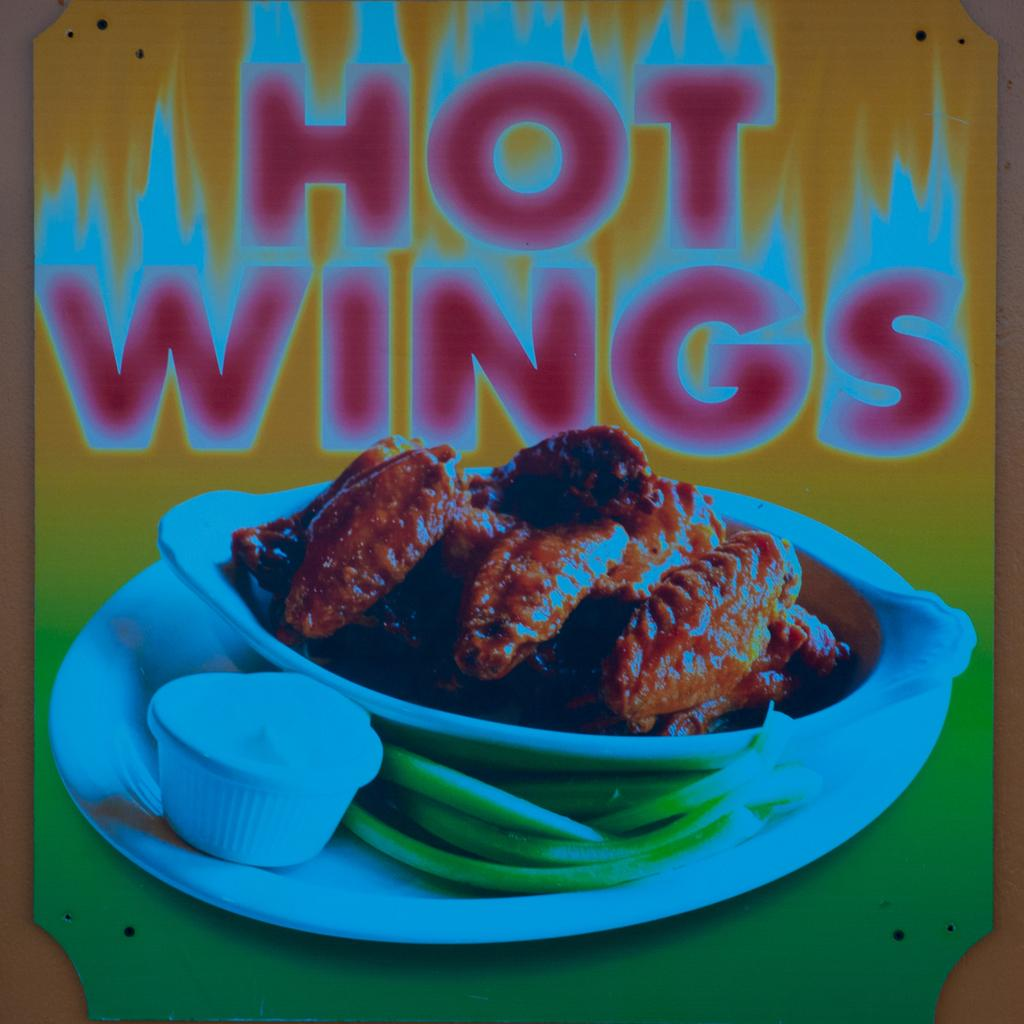What is featured in the image? There is a poster in the image. What is shown on the poster? The poster depicts a food item. Are there any words on the poster? Yes, there is text on the poster. Can you see an arch in the image? There is no arch present in the image; it only features a poster with a food item and text. 